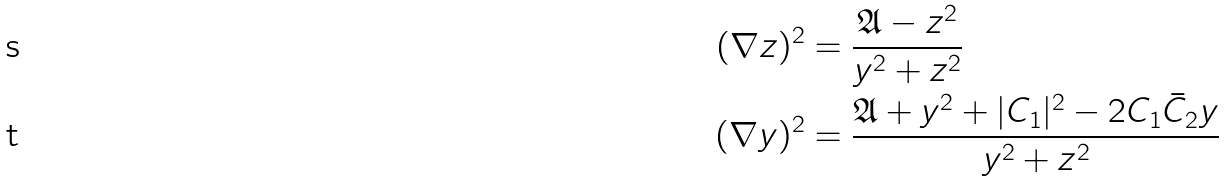<formula> <loc_0><loc_0><loc_500><loc_500>( \nabla z ) ^ { 2 } & = \frac { \mathfrak { A } - z ^ { 2 } } { y ^ { 2 } + z ^ { 2 } } \\ ( \nabla y ) ^ { 2 } & = \frac { \mathfrak { A } + y ^ { 2 } + | C _ { 1 } | ^ { 2 } - 2 C _ { 1 } \bar { C } _ { 2 } y } { y ^ { 2 } + z ^ { 2 } }</formula> 